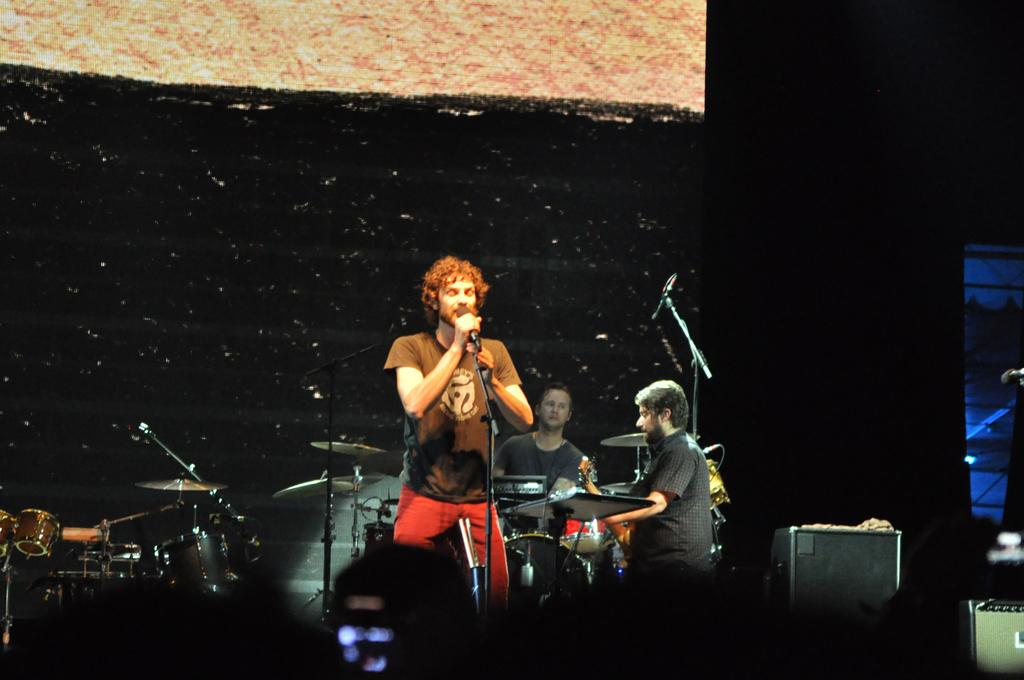What is happening in the image? There is a group of people in the image, and a man is singing in front of a microphone while other people are playing musical instruments. Can you see a dog playing the guitar in the image? No, there is no dog or guitar present in the image. 